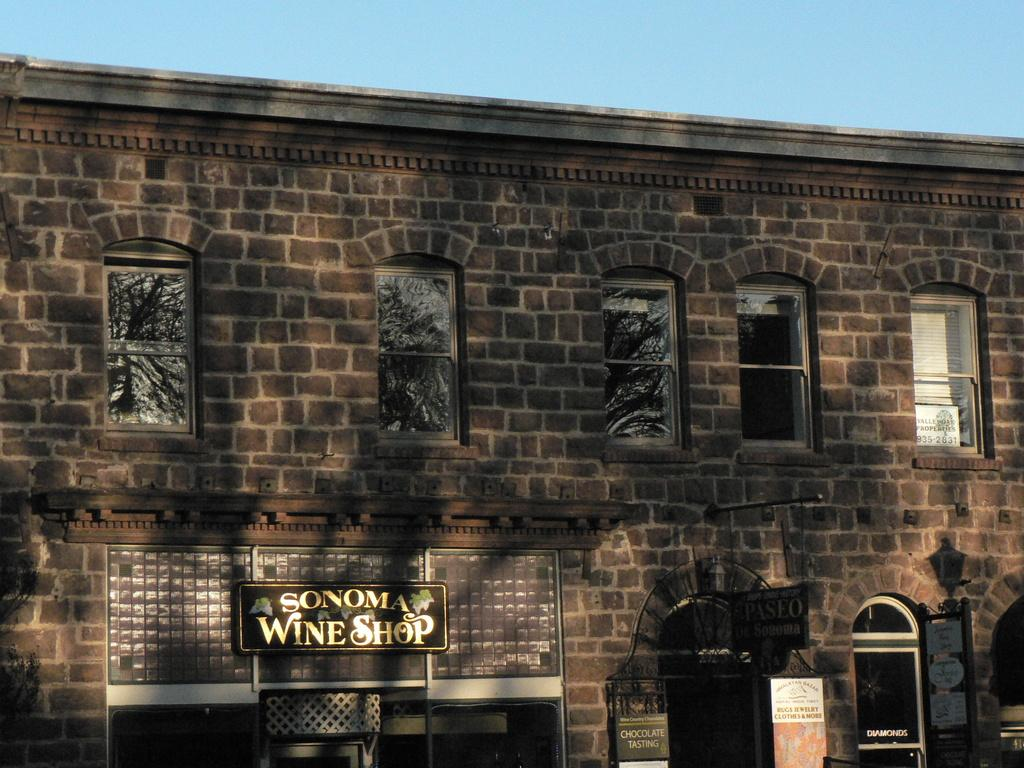<image>
Summarize the visual content of the image. A brick building with the words Sonoma Wine Shop on it 